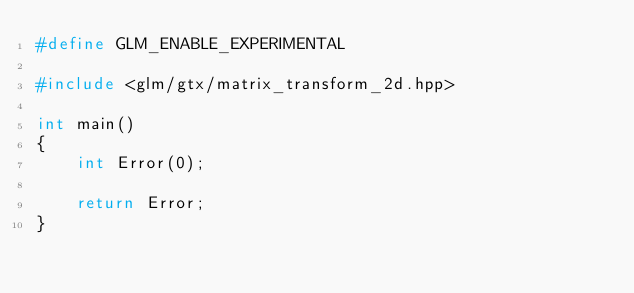Convert code to text. <code><loc_0><loc_0><loc_500><loc_500><_C++_>#define GLM_ENABLE_EXPERIMENTAL

#include <glm/gtx/matrix_transform_2d.hpp>

int main()
{
    int Error(0);

    return Error;
}
</code> 